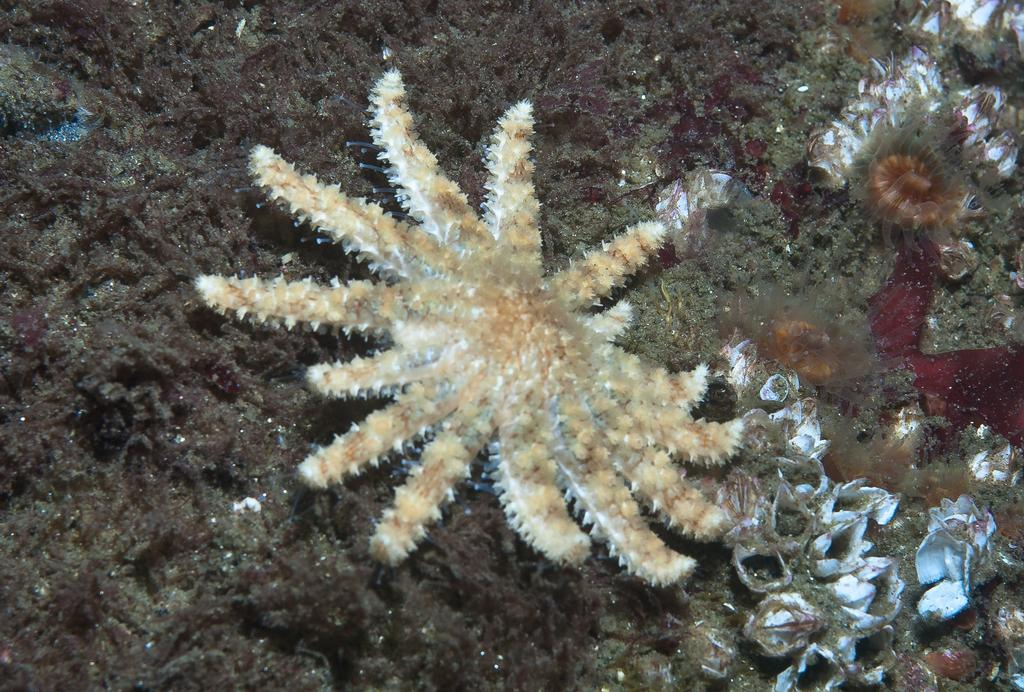How many ants are holding the string attached to the can in the image? There is no image provided, so we cannot determine if there are any ants, string, or cans present. 